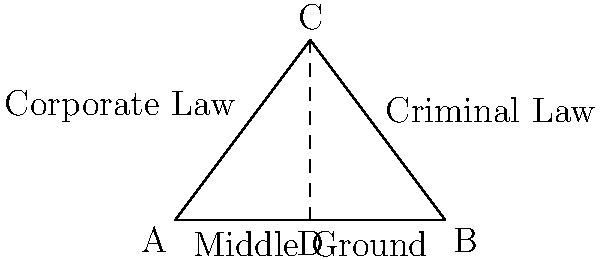In the triangle ABC, where angle C represents the spectrum of legal practice, with side AC representing Corporate Law and side BC representing Criminal Law, the angle bisector CD is drawn. If the length of AB is 6 units, what is the ratio of the length of AD to DB? How might this relate to finding a balance between different areas of law practice? To solve this problem and understand its relevance to balancing different areas of law practice, let's follow these steps:

1) In any triangle, the angle bisector theorem states that the ratio of the lengths of the segments created by the angle bisector on the opposite side is equal to the ratio of the lengths of the other two sides.

2) Mathematically, this is expressed as:
   $$\frac{AD}{DB} = \frac{AC}{BC}$$

3) In this case, we're given that AB = 6 units, and D is the midpoint of AB. This means:
   $$AD = DB = 3$$ units

4) Therefore, the ratio of AD to DB is:
   $$\frac{AD}{DB} = \frac{3}{3} = 1:1$$

5) This 1:1 ratio represents a perfect balance or "middle ground" between the two sides.

6) In the context of law practice:
   - Side AC represents Corporate Law
   - Side BC represents Criminal Law
   - The angle bisector CD represents a balanced approach

7) Just as the angle bisector creates equal ratios on the opposite side, a balanced legal career might involve equal consideration or time devoted to different areas of law.

8) This "middle ground" approach could involve:
   - Developing skills applicable to both corporate and criminal law
   - Exploring practice areas that blend aspects of both (e.g., white-collar crime)
   - Maintaining a diverse caseload to gain experience in multiple areas

9) The 1:1 ratio suggests that finding this balance doesn't necessarily mean choosing one area over another, but rather finding ways to integrate or alternate between different legal specialties.
Answer: 1:1 